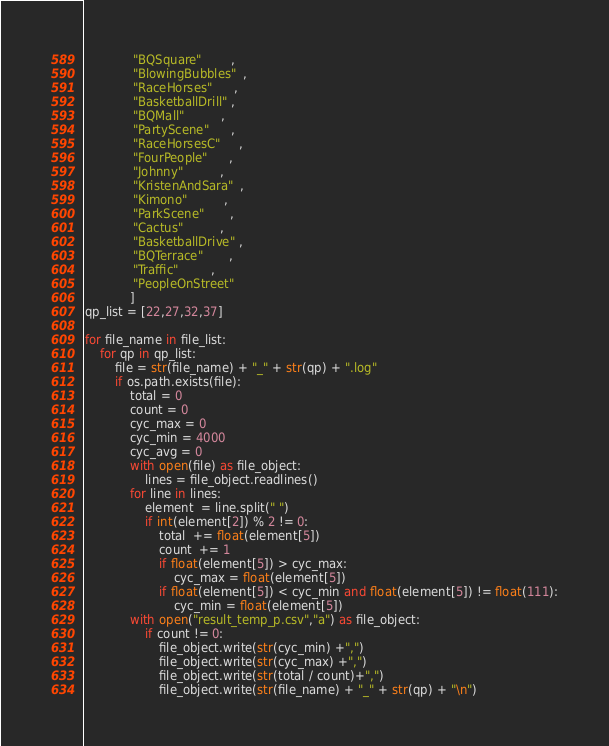<code> <loc_0><loc_0><loc_500><loc_500><_Python_>             "BQSquare"        ,
             "BlowingBubbles"  ,
             "RaceHorses"      ,
             "BasketballDrill" ,
             "BQMall"          ,
             "PartyScene"      ,
             "RaceHorsesC"     ,
             "FourPeople"      ,
             "Johnny"          ,
             "KristenAndSara"  ,
             "Kimono"          ,
             "ParkScene"       ,
             "Cactus"          ,
             "BasketballDrive" ,
             "BQTerrace"       ,
             "Traffic"         ,
             "PeopleOnStreet"
            ]
qp_list = [22,27,32,37]

for file_name in file_list:
    for qp in qp_list:
        file = str(file_name) + "_" + str(qp) + ".log"
        if os.path.exists(file):
            total = 0
            count = 0
            cyc_max = 0
            cyc_min = 4000
            cyc_avg = 0
            with open(file) as file_object:
                lines = file_object.readlines()
            for line in lines:
                element  = line.split(" ")
                if int(element[2]) % 2 != 0: 
                    total  += float(element[5])
                    count  += 1
                    if float(element[5]) > cyc_max:
                        cyc_max = float(element[5])
                    if float(element[5]) < cyc_min and float(element[5]) != float(111):
                        cyc_min = float(element[5])
            with open("result_temp_p.csv","a") as file_object:
                if count != 0:
                    file_object.write(str(cyc_min) +",")
                    file_object.write(str(cyc_max) +",")
                    file_object.write(str(total / count)+",")
                    file_object.write(str(file_name) + "_" + str(qp) + "\n")
</code> 